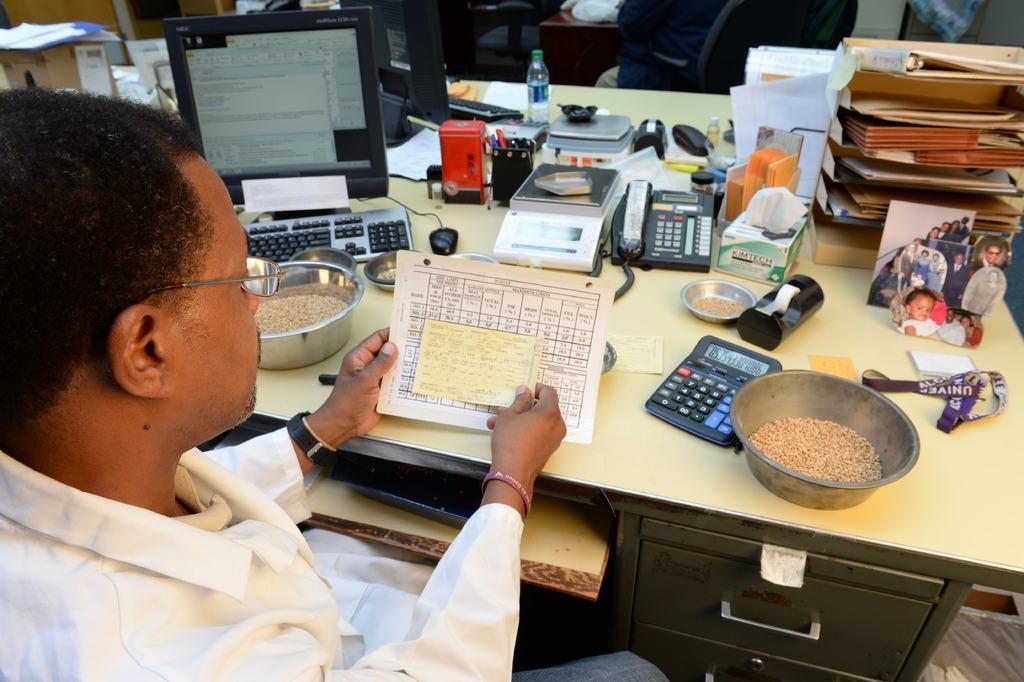Can you describe this image briefly? In this image there is a man sitting. He is holding papers in his hand. In front of him there is a table. On the table there are boxes, a telephone, weighing machines, a water bottle, a computer, bowls, a calculator, photo frames, papers and holders. At the top there are chairs. In the top left there are cardboard boxes. 